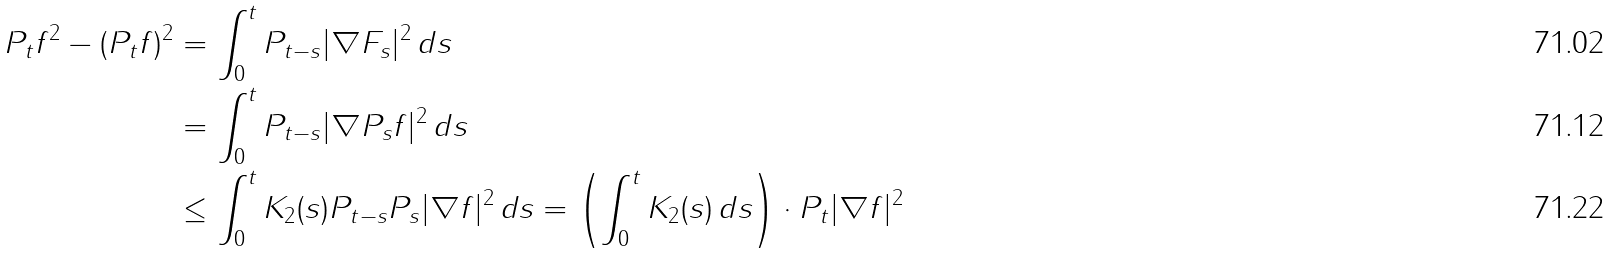<formula> <loc_0><loc_0><loc_500><loc_500>P _ { t } f ^ { 2 } - ( P _ { t } f ) ^ { 2 } & = \int _ { 0 } ^ { t } P _ { t - s } | \nabla F _ { s } | ^ { 2 } \, d s \\ & = \int _ { 0 } ^ { t } P _ { t - s } | \nabla P _ { s } f | ^ { 2 } \, d s \\ & \leq \int _ { 0 } ^ { t } K _ { 2 } ( s ) P _ { t - s } P _ { s } | \nabla f | ^ { 2 } \, d s = \left ( \int _ { 0 } ^ { t } K _ { 2 } ( s ) \, d s \right ) \cdot P _ { t } | \nabla f | ^ { 2 }</formula> 